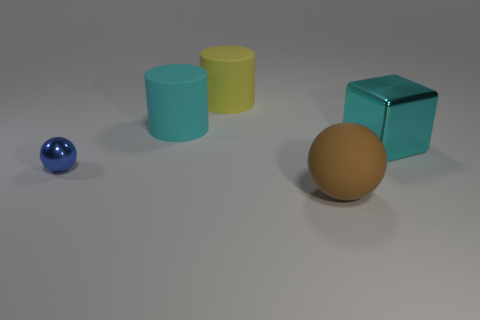Subtract all cylinders. How many objects are left? 3 Add 1 big yellow cylinders. How many objects exist? 6 Subtract all big gray blocks. Subtract all big rubber balls. How many objects are left? 4 Add 1 big cyan rubber things. How many big cyan rubber things are left? 2 Add 1 cyan blocks. How many cyan blocks exist? 2 Subtract 0 yellow cubes. How many objects are left? 5 